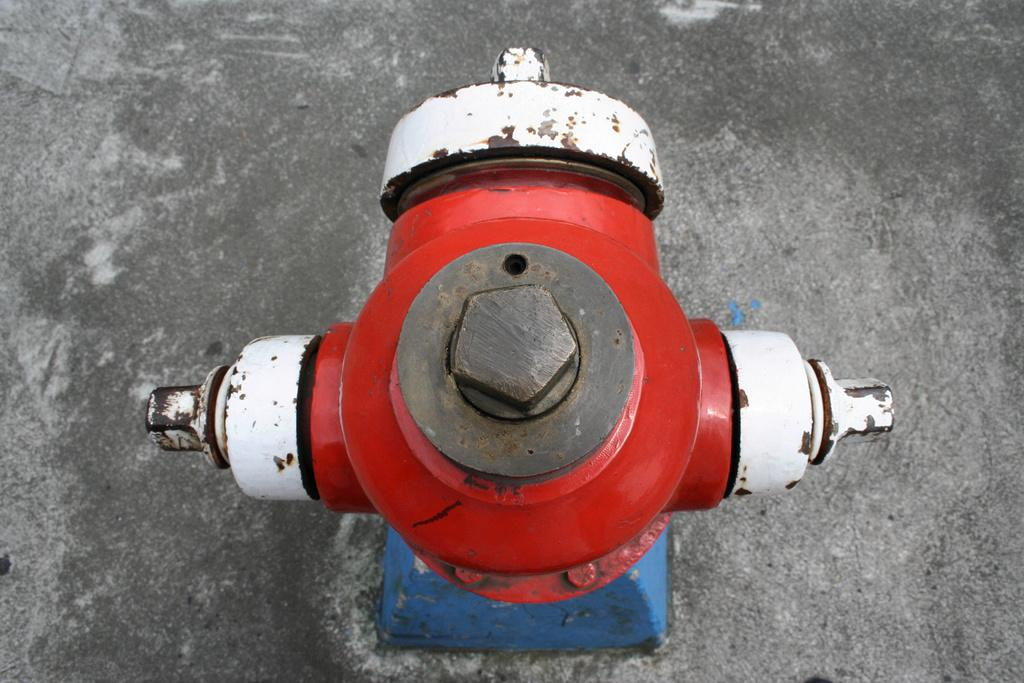What object can be seen in the image? There is a hydrant in the image. Where is the hydrant located? The hydrant is located on the road. What type of pancake can be seen on the hydrant in the image? There is no pancake present on the hydrant in the image. 